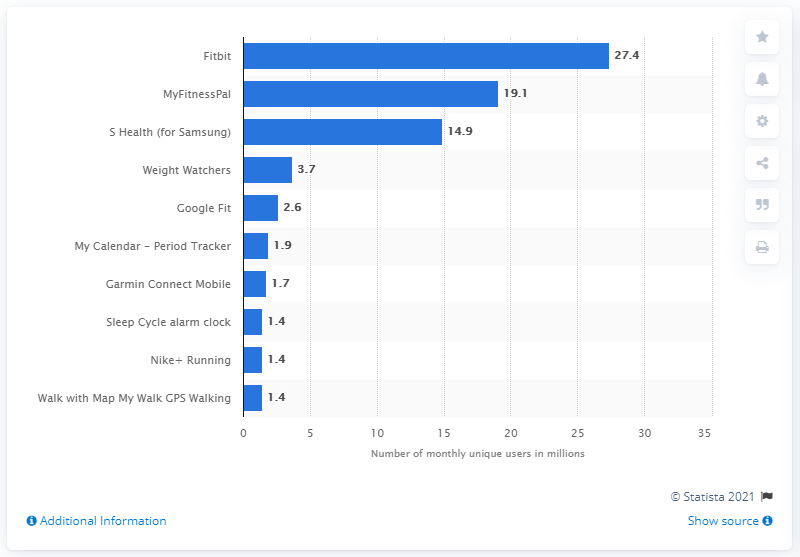Identify some key points in this picture. MyFitnessPal, a popular fitness app, was ranked second with 19.1 million users. As of May 2018, Fitbit had approximately 27.4 unique users. 